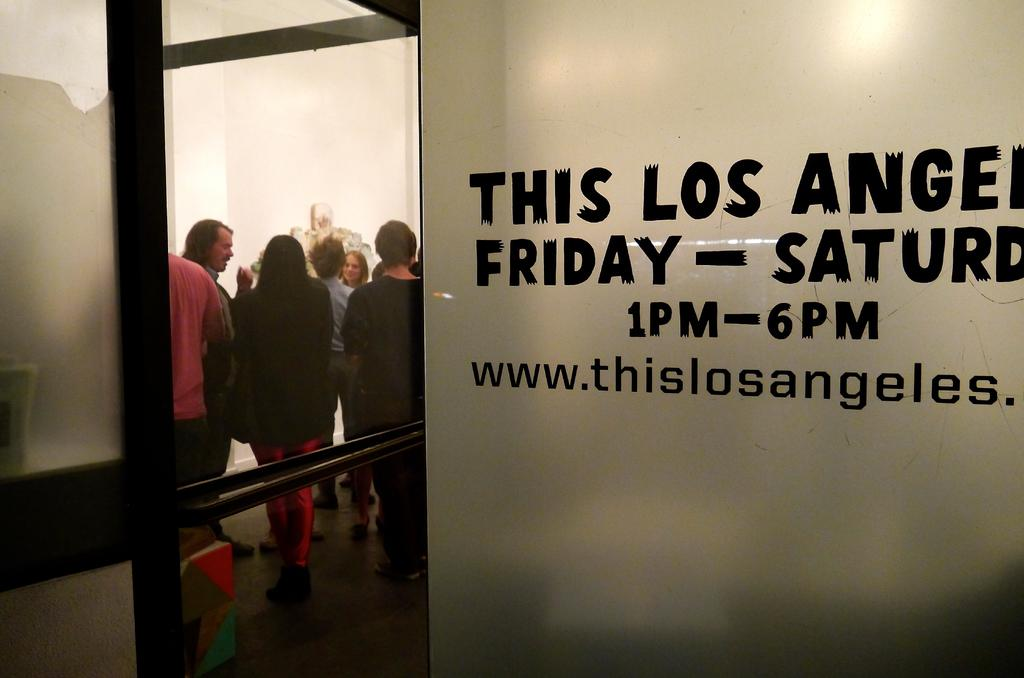Provide a one-sentence caption for the provided image. Inside of a Los Angeles office are people standing in a room. 